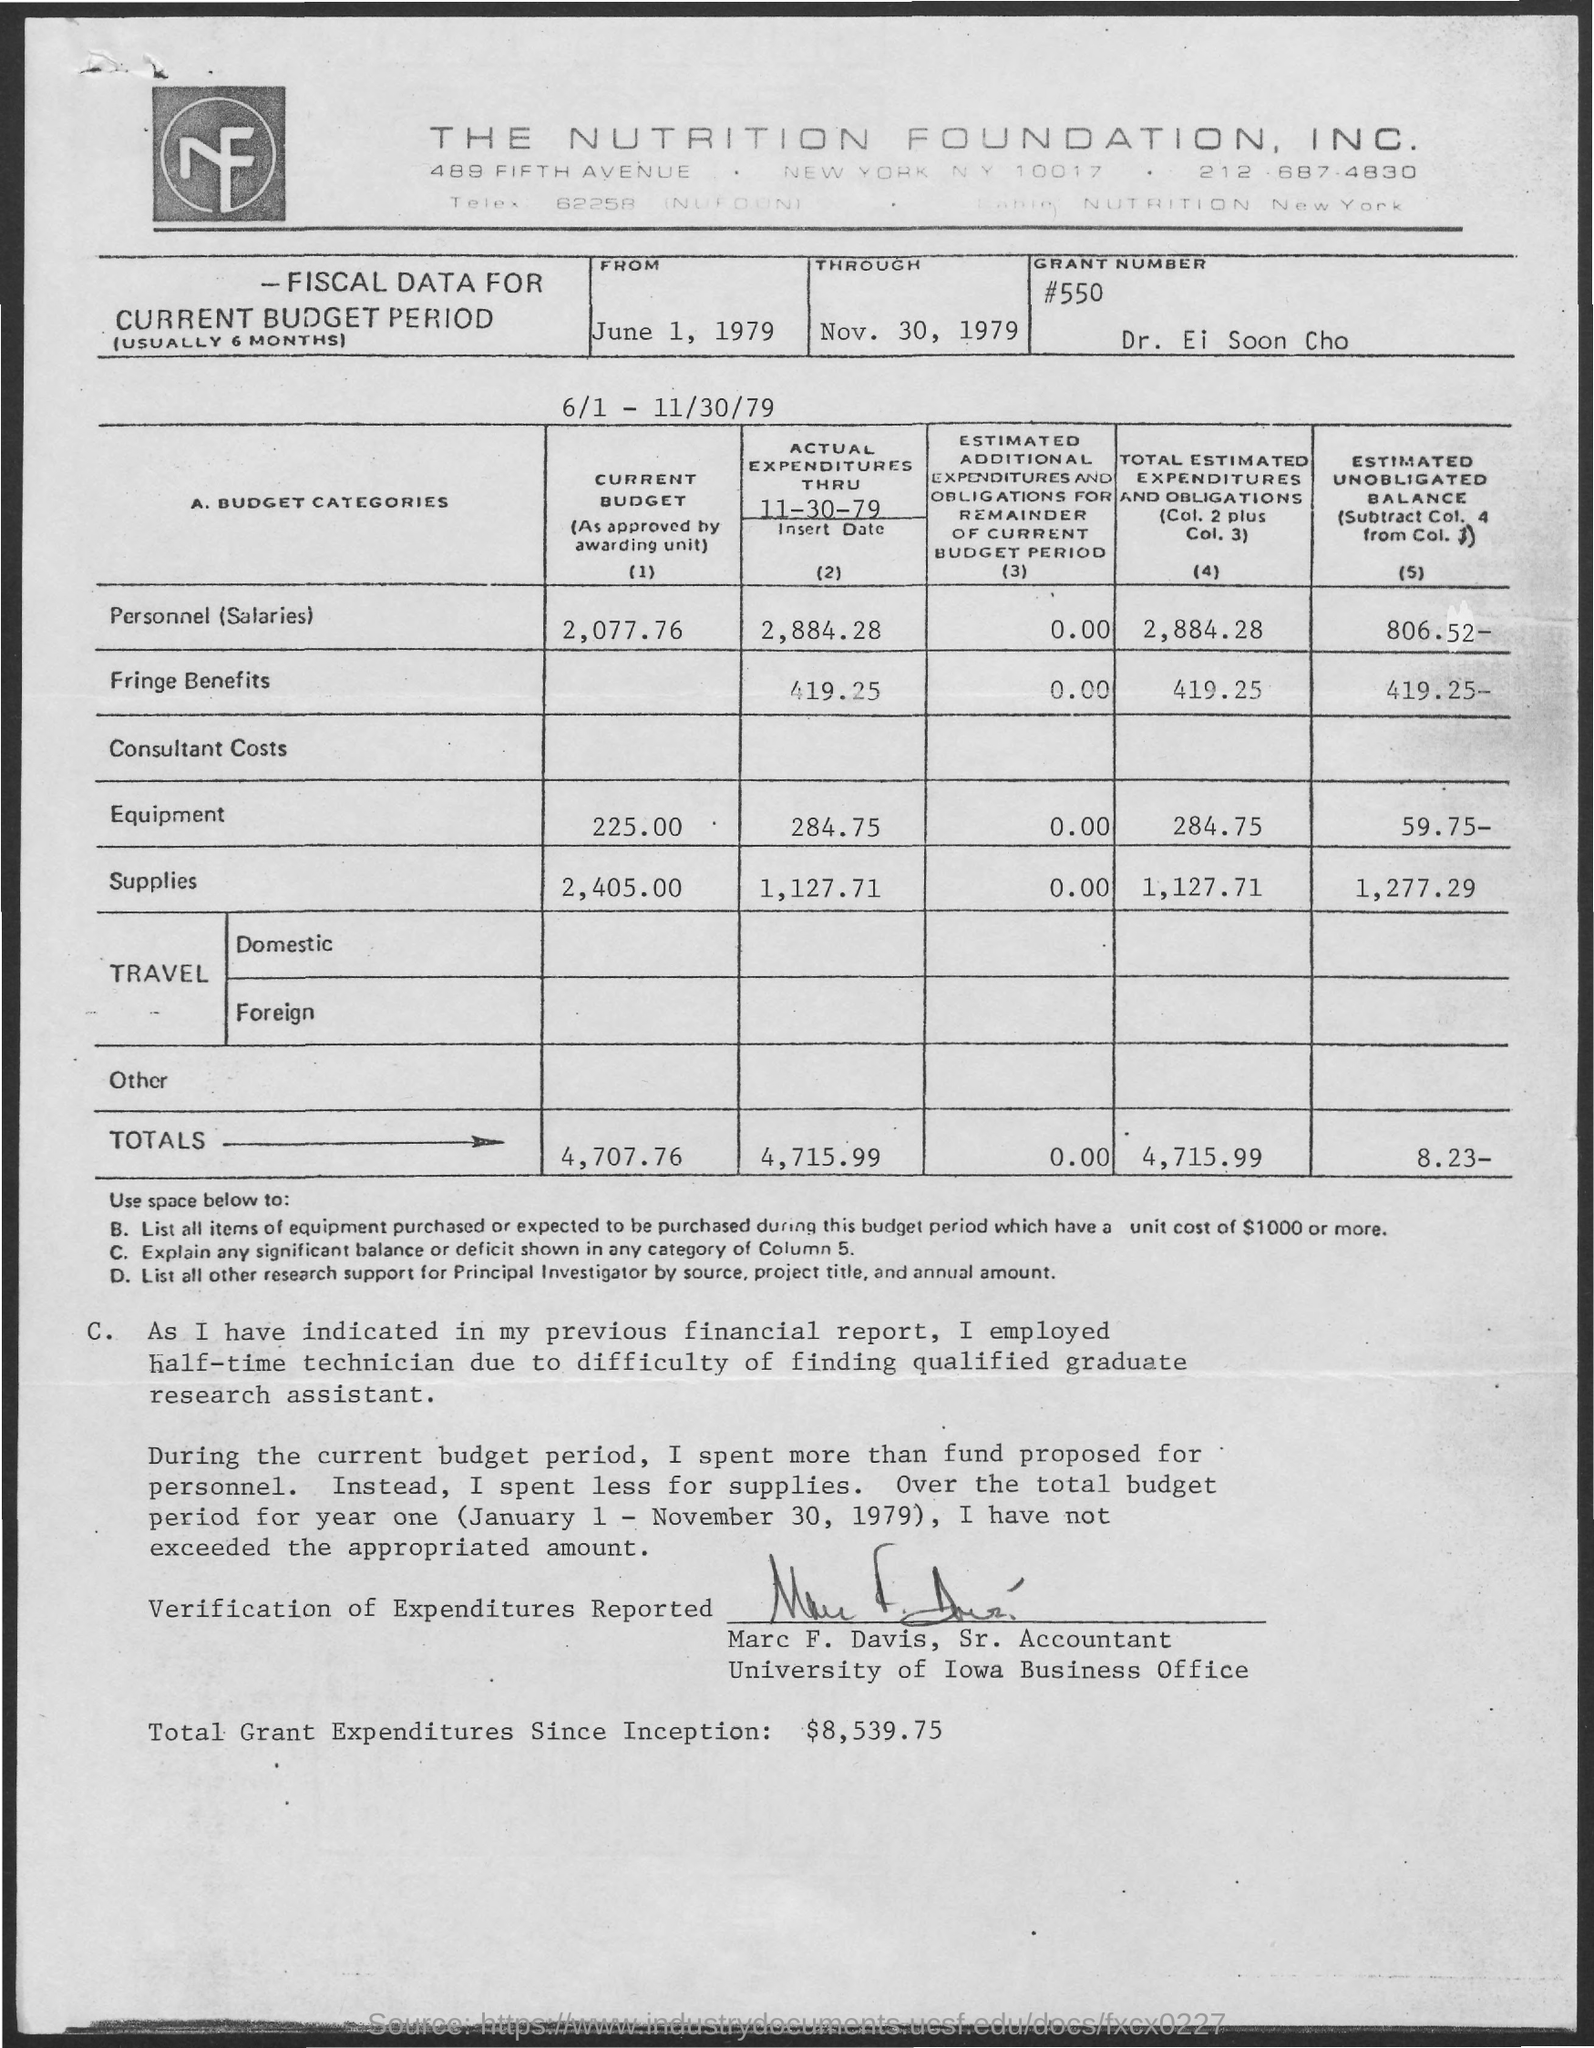What is the grant number mentioned in the given letter ?
Your response must be concise. #550. What is the amount of personnel (salaries) in the current budget ?
Keep it short and to the point. 2,077.76. What is the amount of equipment in the current budget ?
Your answer should be compact. 225.00. What is the amount  of supplies in the current budget ?
Your response must be concise. 2,405. What is the total amount shown in the current budget ?
Give a very brief answer. 4,707.76. What is the designation of marc f. davis ?
Your answer should be compact. Sr. Accountant. What is the total amount of actual expenditures mentioned in the given page ?
Make the answer very short. 4,715.99. What is the total amount  of estimated unobligated balance shown in the given page ?
Offer a very short reply. 8.23-. 